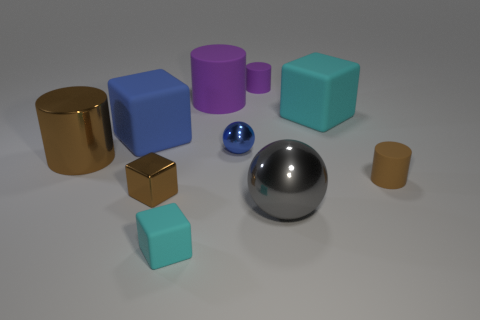What do you think is the context or setting of this collection of objects? This appears to be a staged scene, possibly for a visual study or a digital rendering. The objects might be part of a modeling or rendering software showcase, designed to demonstrate lighting effects and texture rendering, with an emphasis on simple geometric shapes and distinct colors. 